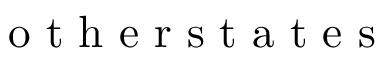<formula> <loc_0><loc_0><loc_500><loc_500>o t h e r s t a t e s</formula> 